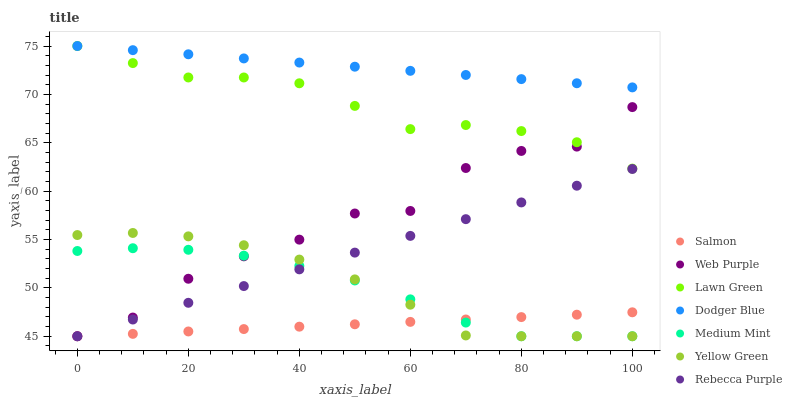Does Salmon have the minimum area under the curve?
Answer yes or no. Yes. Does Dodger Blue have the maximum area under the curve?
Answer yes or no. Yes. Does Lawn Green have the minimum area under the curve?
Answer yes or no. No. Does Lawn Green have the maximum area under the curve?
Answer yes or no. No. Is Dodger Blue the smoothest?
Answer yes or no. Yes. Is Web Purple the roughest?
Answer yes or no. Yes. Is Lawn Green the smoothest?
Answer yes or no. No. Is Lawn Green the roughest?
Answer yes or no. No. Does Medium Mint have the lowest value?
Answer yes or no. Yes. Does Lawn Green have the lowest value?
Answer yes or no. No. Does Dodger Blue have the highest value?
Answer yes or no. Yes. Does Yellow Green have the highest value?
Answer yes or no. No. Is Web Purple less than Dodger Blue?
Answer yes or no. Yes. Is Dodger Blue greater than Rebecca Purple?
Answer yes or no. Yes. Does Rebecca Purple intersect Web Purple?
Answer yes or no. Yes. Is Rebecca Purple less than Web Purple?
Answer yes or no. No. Is Rebecca Purple greater than Web Purple?
Answer yes or no. No. Does Web Purple intersect Dodger Blue?
Answer yes or no. No. 